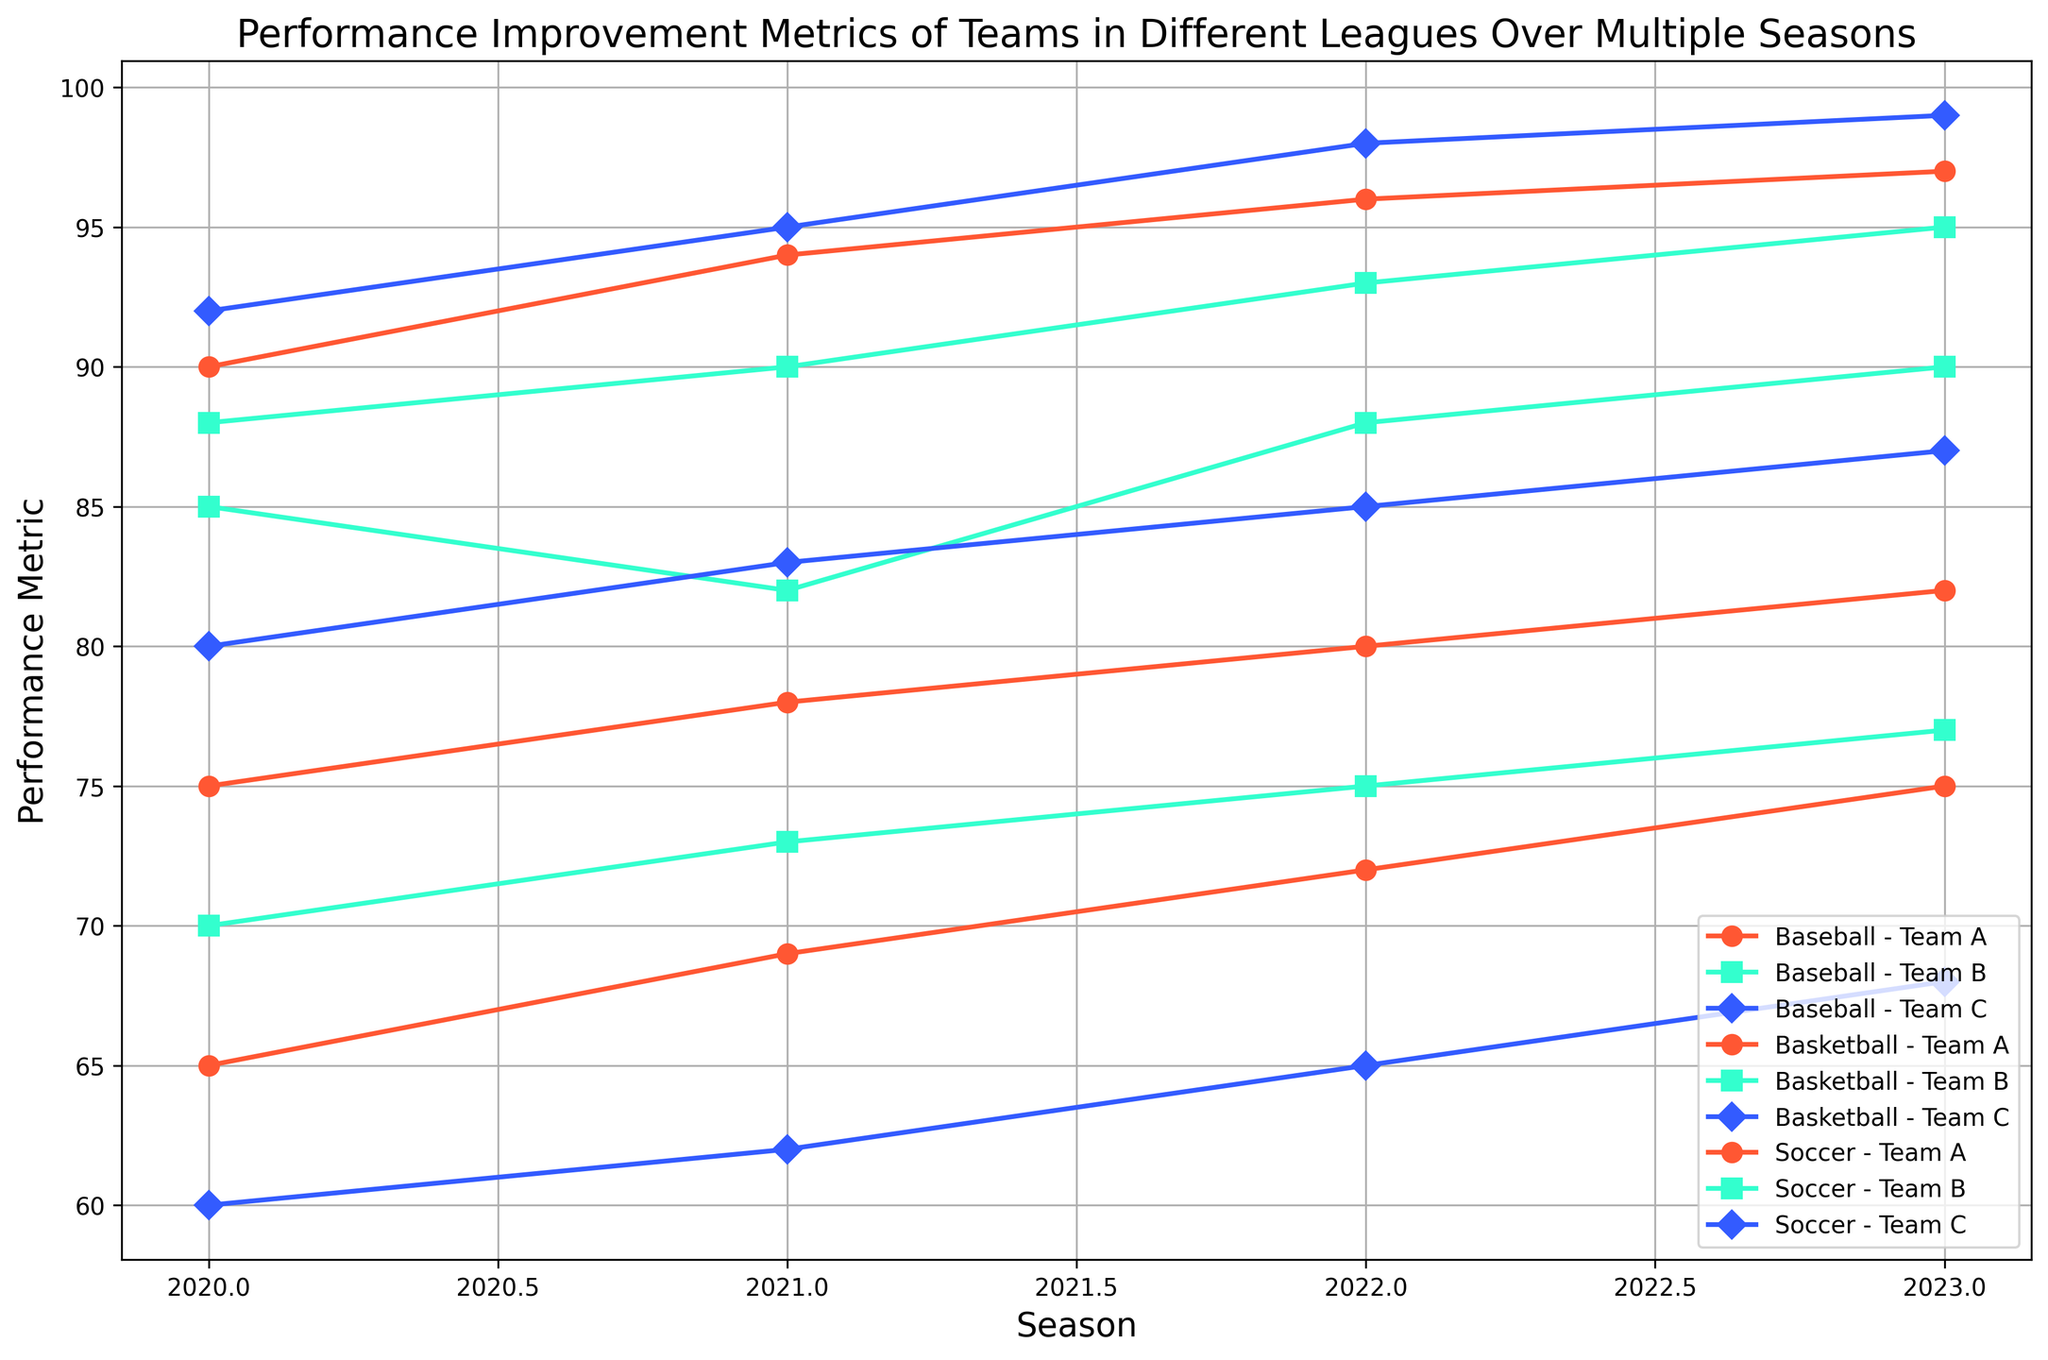What's the average Performance Metric for Team A across all leagues in 2023? First, identify the Performance Metrics for Team A in each league for the year 2023: Baseball (82), Basketball (75), Soccer (97). Sum these values: 82 + 75 + 97 = 254. Then divide by the number of leagues (3): 254 / 3 ≈ 84.67.
Answer: 84.67 Which team had the highest Performance Metric in Soccer in 2022? Check the Performance Metrics for all Soccer teams in 2022: Team A (96), Team B (93), Team C (98). Team C has the highest metric with 98.
Answer: Team C Did Team B in Basketball improve or decline in performance from 2022 to 2023? Look at the Performance Metrics for Team B in Basketball: 2022 (75), 2023 (77). Since 77 (2023) is greater than 75 (2022), Team B improved.
Answer: Improved What is the difference in Performance Metric between Team B and Team C in Baseball in 2021? Identify the Performance Metrics for Team B (82) and Team C (83) in Baseball in 2021. Calculate the difference: 83 - 82 = 1.
Answer: 1 Which league showed the most improvement in Team A's Performance Metric from 2020 to 2023? Evaluate Team A's metrics in each league from 2020 to 2023: Baseball (75 to 82), Basketball (65 to 75), Soccer (90 to 97). Calculate the difference for each: Baseball (7), Basketball (10), Soccer (7). Basketball shows the most improvement with a 10-point increase.
Answer: Basketball What was the median Performance Metric across all Basketball teams in 2020? List the Performance Metrics for Basketball teams in 2020: 65, 70, 60. Arrange them in sorted order: 60, 65, 70. The median value is the middle one, which is 65.
Answer: 65 Which team had the most consistent Performance Metric in Baseball from 2020 to 2023? Look at the range of Performance Metrics for each Baseball team from 2020 to 2023: Team A (75, 78, 80, 82), Team B (85, 82, 88, 90), Team C (80, 83, 85, 87). Team A ranges from 75 to 82 (7 points), Team B ranges from 82 to 90 (8 points), Team C ranges from 80 to 87 (7 points). Team A and Team C both have the smallest range (7 points).
Answer: Team A and Team C 